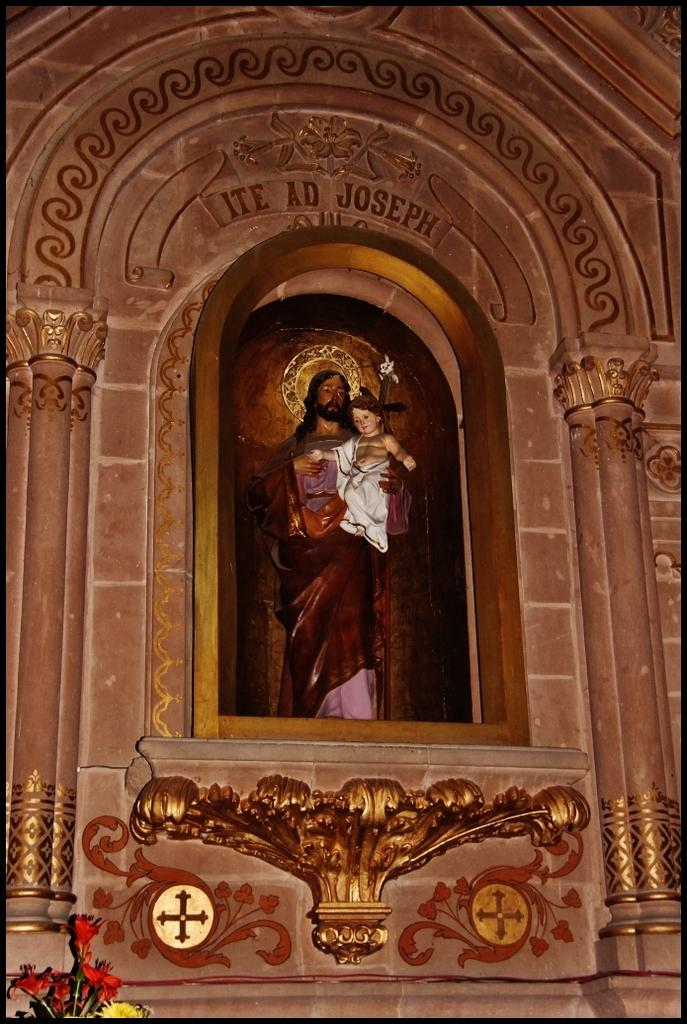What type of structure can be seen in the image? There is an arch in the image. What artistic element is present in the image? There is a sculpture in the image. Is there any text visible in the image? Yes, there is written text in the image. What type of vegetation is at the bottom of the image? There are flowers at the bottom of the image. What time of day is the goose depicted in the image? There is no goose present in the image. What type of bomb is shown in the image? There is no bomb present in the image. 